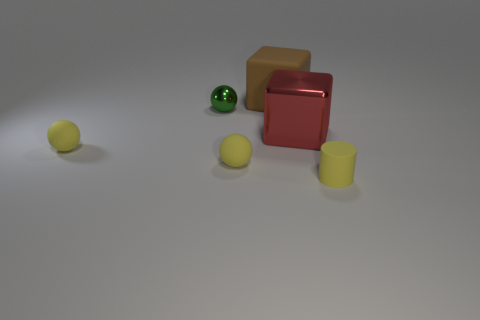How many other things are there of the same color as the small cylinder?
Keep it short and to the point. 2. What shape is the rubber thing behind the large red block?
Provide a short and direct response. Cube. What number of things are either balls or gray matte things?
Ensure brevity in your answer.  3. There is a yellow matte cylinder; is it the same size as the cube behind the big metal block?
Offer a very short reply. No. What number of other objects are there of the same material as the small cylinder?
Offer a terse response. 3. What number of things are shiny things that are on the right side of the brown rubber thing or small matte things on the left side of the rubber cube?
Offer a terse response. 3. What is the material of the other object that is the same shape as the big red object?
Make the answer very short. Rubber. Are there any tiny green things?
Your answer should be compact. Yes. There is a yellow matte object that is to the right of the small green object and to the left of the cylinder; what is its size?
Ensure brevity in your answer.  Small. The red shiny thing is what shape?
Provide a short and direct response. Cube. 